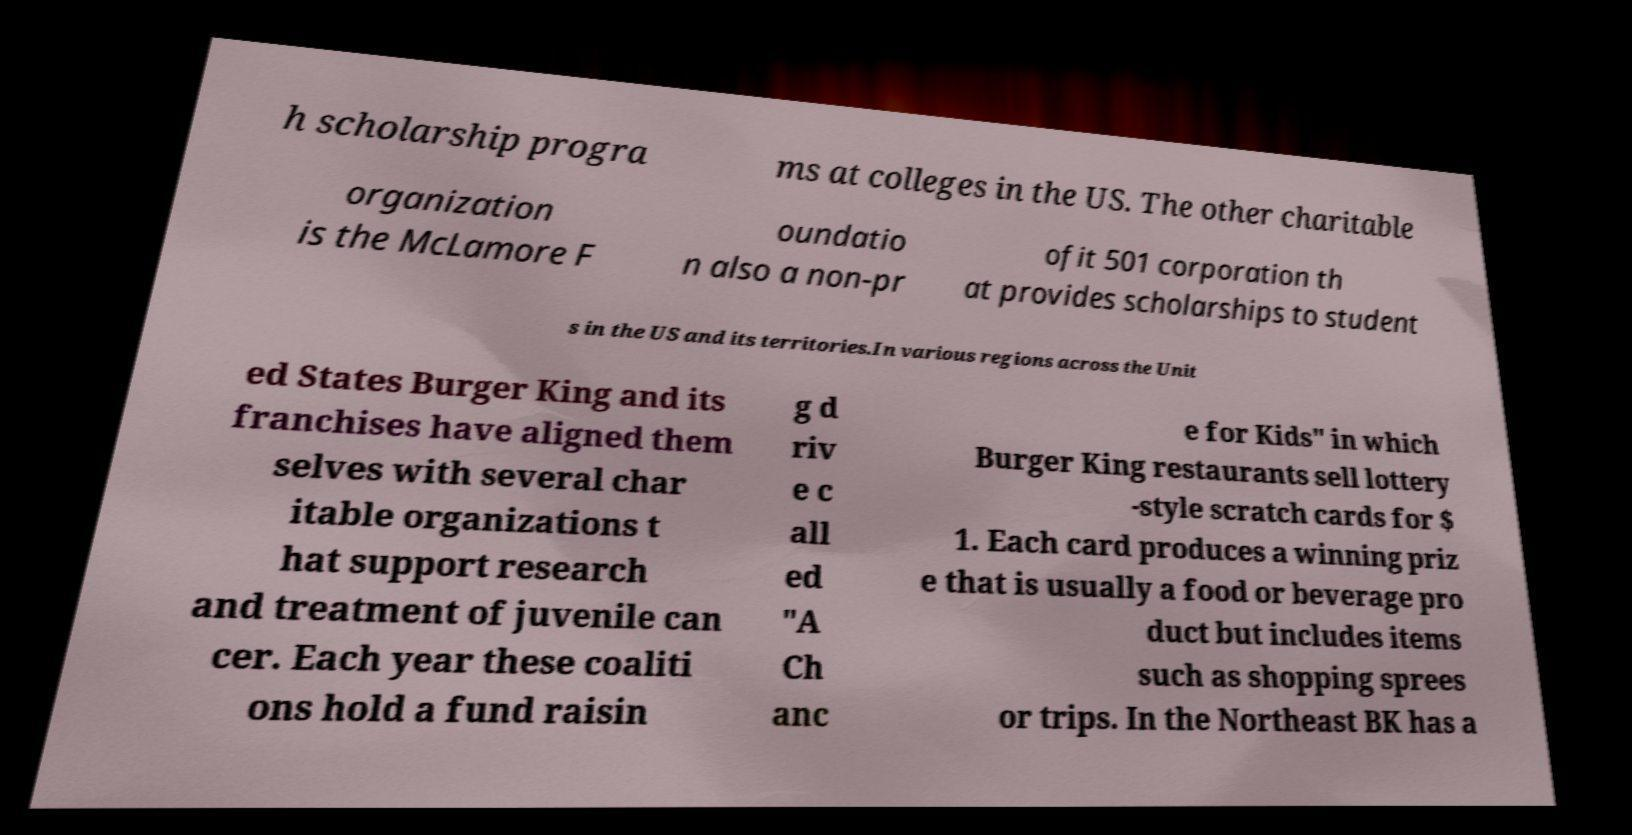Could you extract and type out the text from this image? h scholarship progra ms at colleges in the US. The other charitable organization is the McLamore F oundatio n also a non-pr ofit 501 corporation th at provides scholarships to student s in the US and its territories.In various regions across the Unit ed States Burger King and its franchises have aligned them selves with several char itable organizations t hat support research and treatment of juvenile can cer. Each year these coaliti ons hold a fund raisin g d riv e c all ed "A Ch anc e for Kids" in which Burger King restaurants sell lottery -style scratch cards for $ 1. Each card produces a winning priz e that is usually a food or beverage pro duct but includes items such as shopping sprees or trips. In the Northeast BK has a 